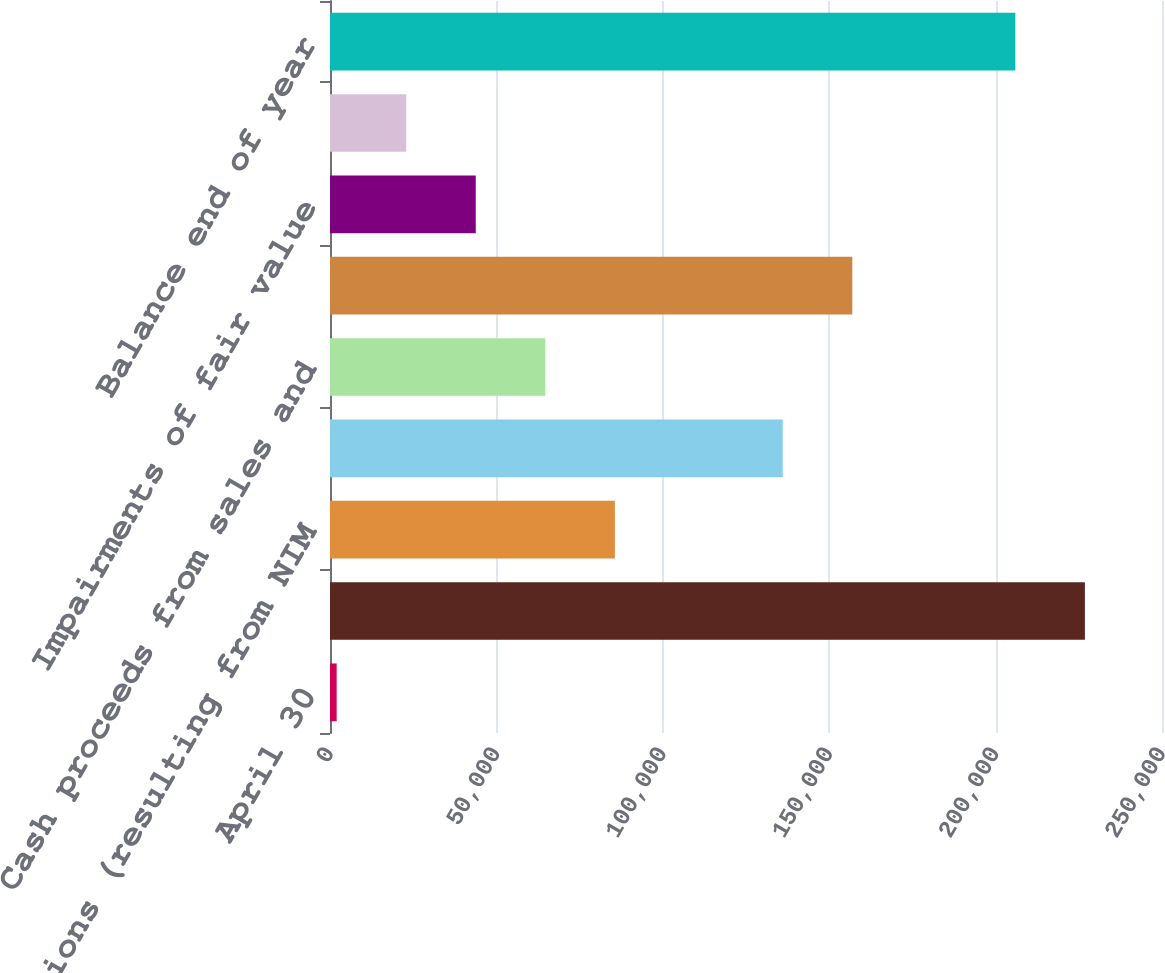Convert chart to OTSL. <chart><loc_0><loc_0><loc_500><loc_500><bar_chart><fcel>April 30<fcel>Balance beginning of year<fcel>Additions (resulting from NIM<fcel>Cash received<fcel>Cash proceeds from sales and<fcel>Accretion<fcel>Impairments of fair value<fcel>Change in unrealized holding<fcel>Balance end of year<nl><fcel>2005<fcel>226833<fcel>85592.2<fcel>136045<fcel>64695.4<fcel>156942<fcel>43798.6<fcel>22901.8<fcel>205936<nl></chart> 